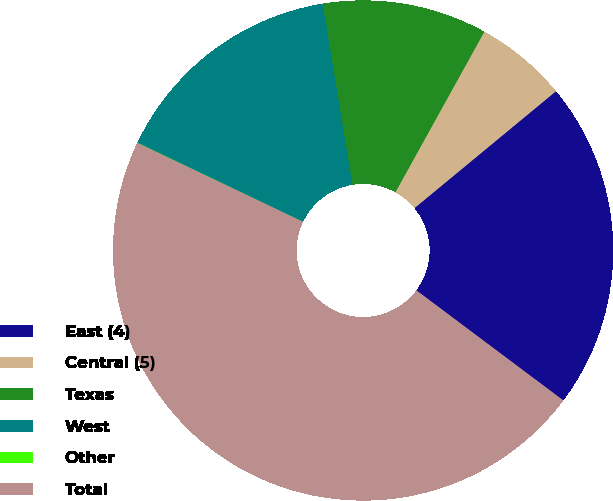<chart> <loc_0><loc_0><loc_500><loc_500><pie_chart><fcel>East (4)<fcel>Central (5)<fcel>Texas<fcel>West<fcel>Other<fcel>Total<nl><fcel>21.22%<fcel>5.96%<fcel>10.64%<fcel>15.32%<fcel>0.02%<fcel>46.84%<nl></chart> 